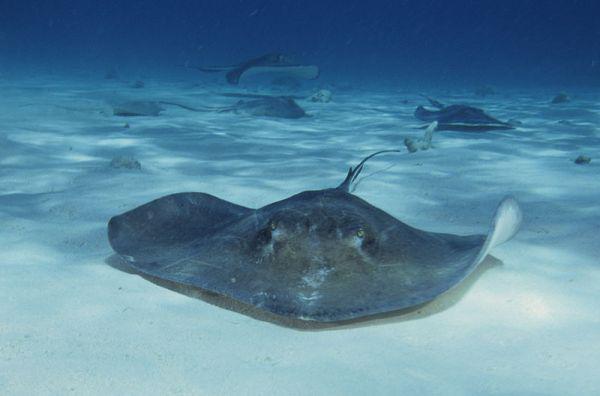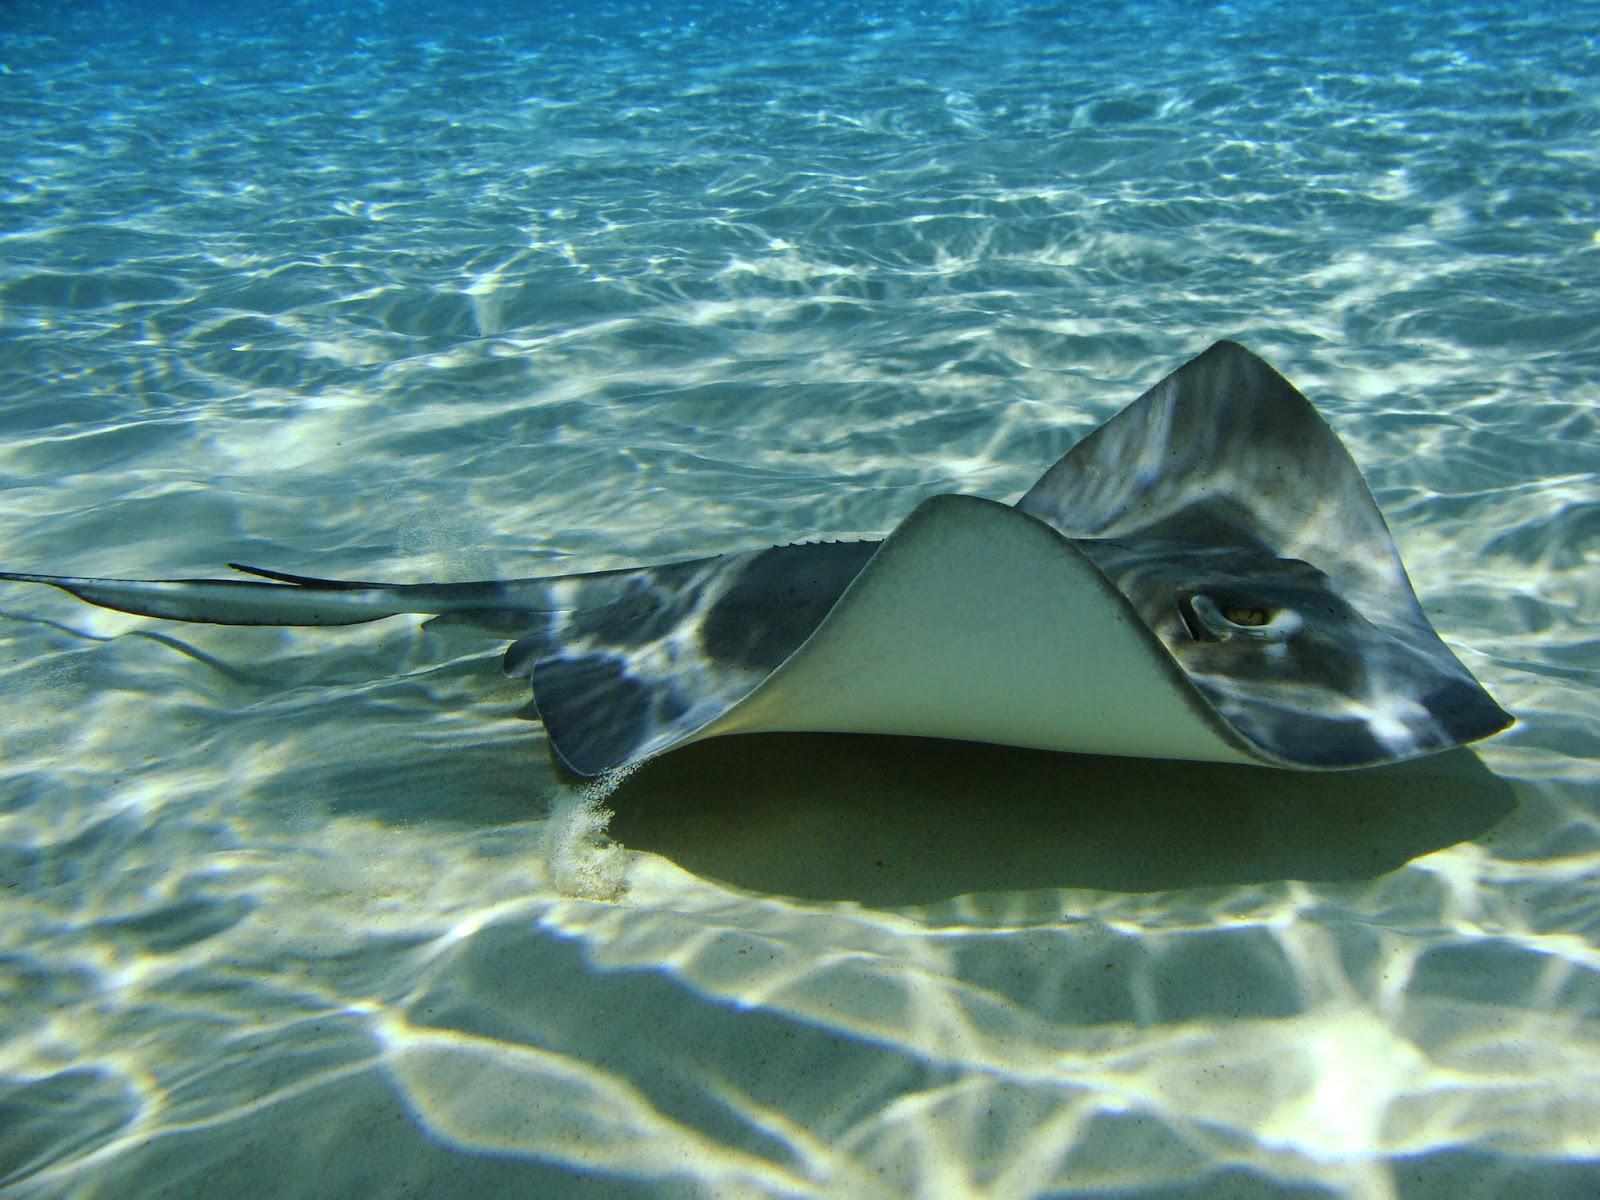The first image is the image on the left, the second image is the image on the right. Examine the images to the left and right. Is the description "No image contains more than three stingray in the foreground, and no image contains other types of fish." accurate? Answer yes or no. Yes. 